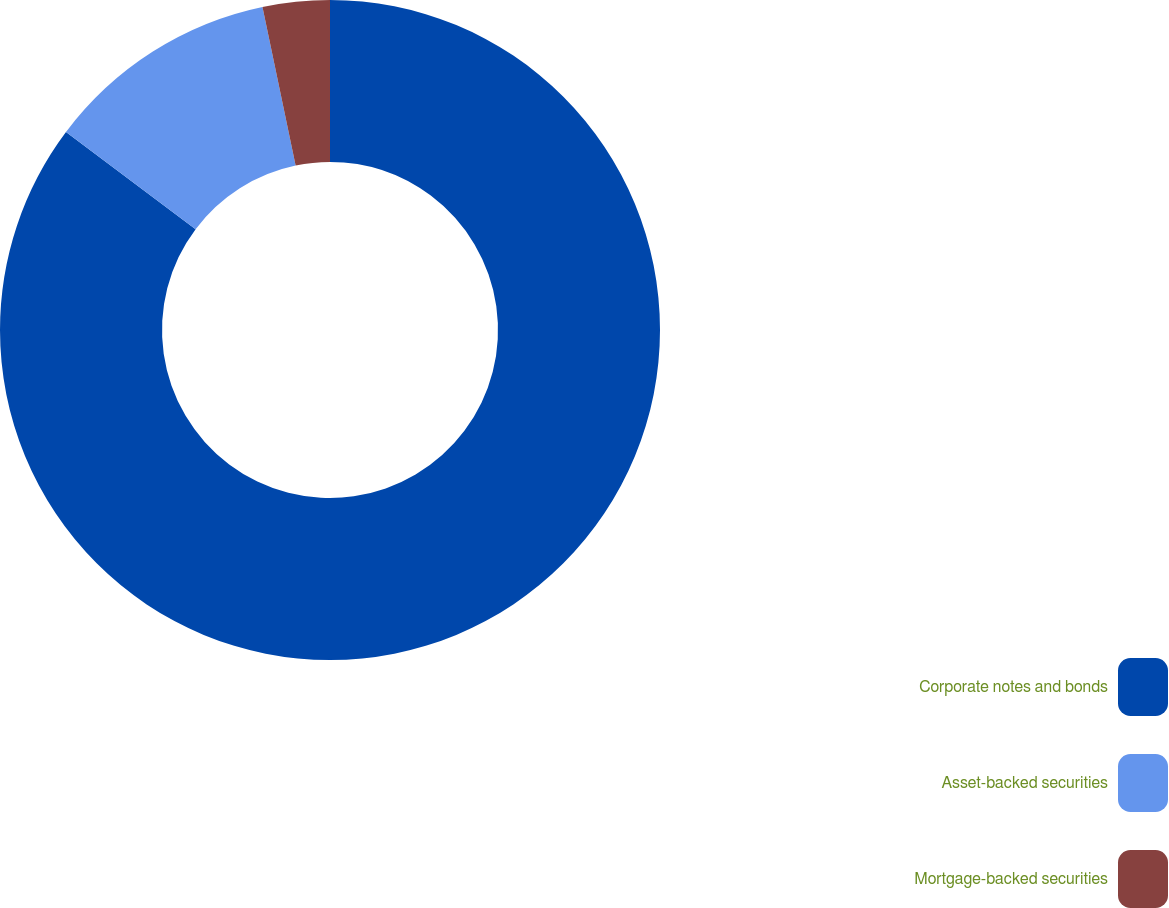Convert chart. <chart><loc_0><loc_0><loc_500><loc_500><pie_chart><fcel>Corporate notes and bonds<fcel>Asset-backed securities<fcel>Mortgage-backed securities<nl><fcel>85.25%<fcel>11.48%<fcel>3.28%<nl></chart> 